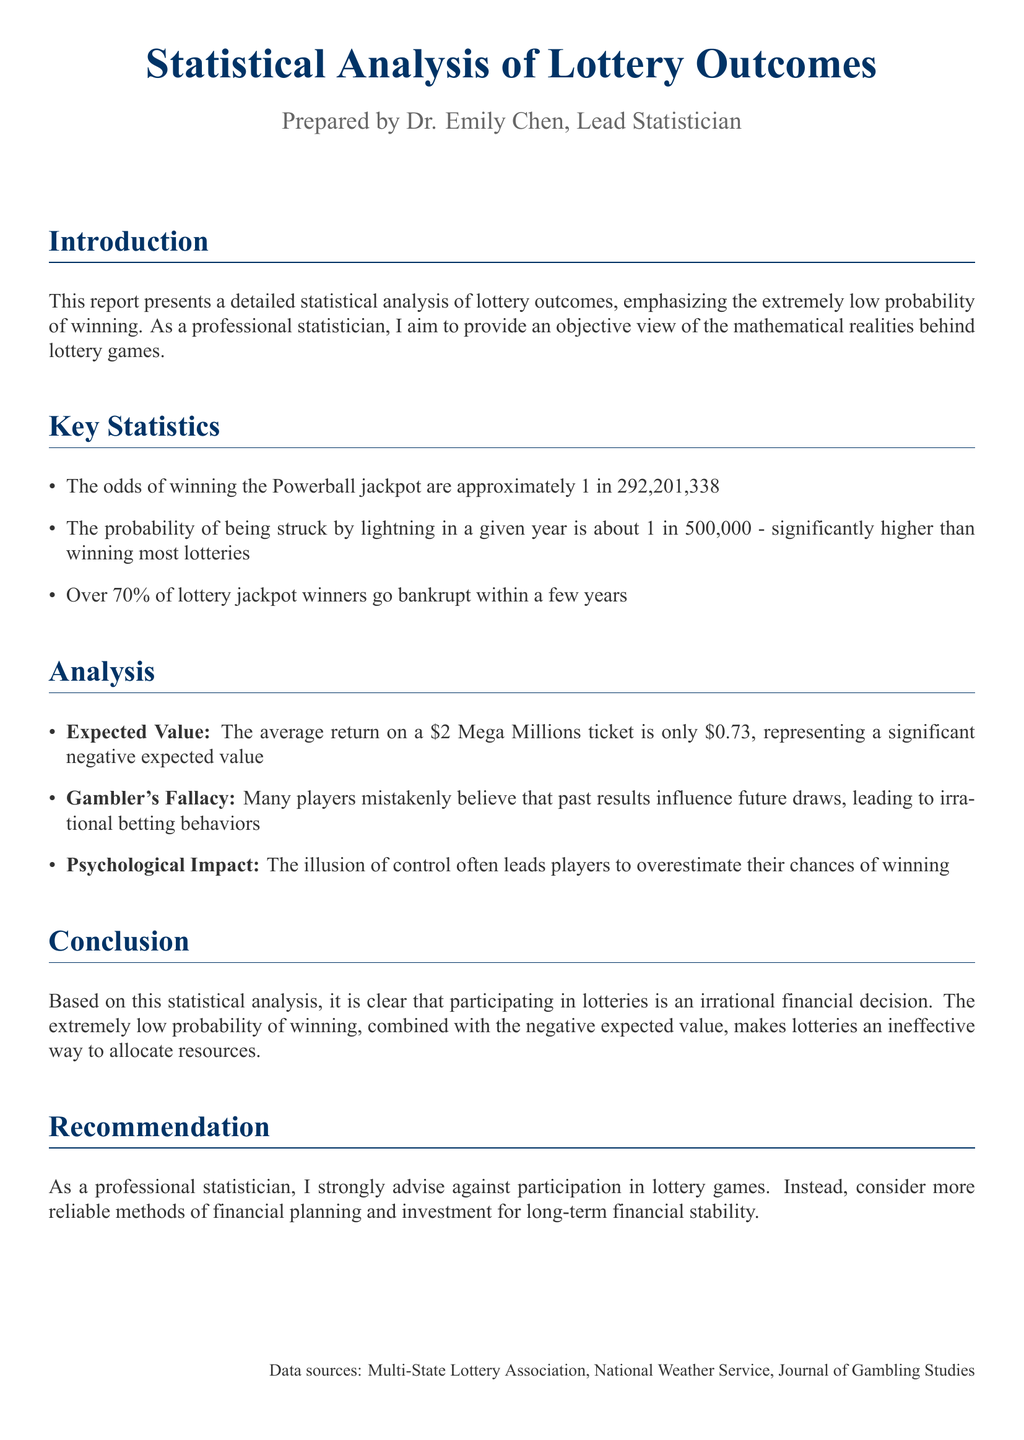What are the odds of winning the Powerball jackpot? The odds are given specifically in the document, which states that the odds are approximately 1 in 292,201,338.
Answer: 1 in 292,201,338 What percentage of lottery jackpot winners go bankrupt? The document mentions that over 70% of jackpot winners face bankruptcy within a few years.
Answer: 70% What is the average return on a $2 Mega Millions ticket? The document provides this information, indicating that the average return is only $0.73.
Answer: $0.73 Who prepared the report? The introductory section specifies that Dr. Emily Chen is the lead statistician who prepared this report.
Answer: Dr. Emily Chen What fallacy do many lottery players mistakenly believe in? The term used in the document to describe this reasoning error is "Gambler's Fallacy."
Answer: Gambler's Fallacy What is the conclusion drawn about lotteries in this report? The conclusion section summarizes the author's stance, stating that participating in lotteries is an irrational financial decision.
Answer: Irrational financial decision What is recommended instead of lottery participation? The recommendation clearly states to consider more reliable methods of financial planning and investment.
Answer: Reliable methods of financial planning and investment What is the psychological impact mentioned in the document? The document discusses the illusion of control, which leads players to overestimate their chances of winning.
Answer: Illusion of control 